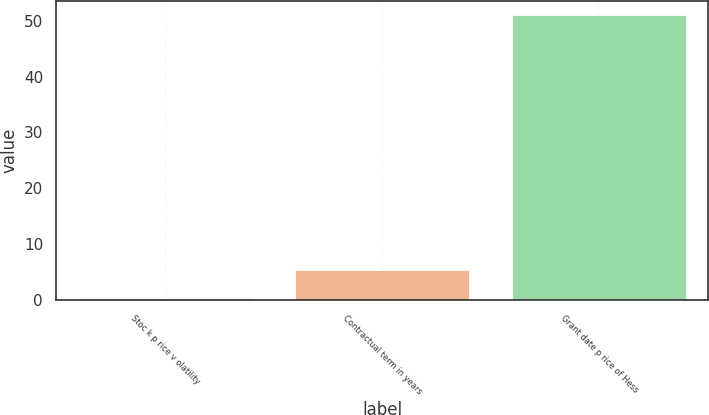Convert chart. <chart><loc_0><loc_0><loc_500><loc_500><bar_chart><fcel>Stoc k p rice v olatility<fcel>Contractual term in years<fcel>Grant date p rice of Hess<nl><fcel>0.39<fcel>5.45<fcel>51.03<nl></chart> 